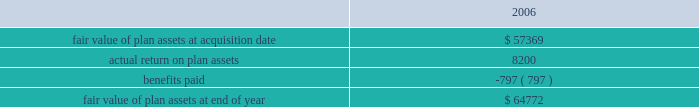For the valuation of the 4199466 performance-based options granted in 2005 : the risk free interest rate was 4.2% ( 4.2 % ) , the volatility factor for the expected market price of the common stock was 44% ( 44 % ) , the expected dividend yield was zero and the objective time to exercise was 4.7 years with an objective in the money assumption of 2.95 years .
It was also expected that the initial public offering assumption would occur within a 9 month period from grant date .
The fair value of the performance-based options was calculated to be $ 5.85 .
The fair value for fis options granted in 2006 was estimated at the date of grant using a black-scholes option- pricing model with the following weighted average assumptions .
The risk free interest rates used in the calculation are the rate that corresponds to the weighted average expected life of an option .
The risk free interest rate used for options granted during 2006 was 4.9% ( 4.9 % ) .
A volatility factor for the expected market price of the common stock of 30% ( 30 % ) was used for options granted in 2006 .
The expected dividend yield used for 2006 was 0.5% ( 0.5 % ) .
A weighted average expected life of 6.4 years was used for 2006 .
The weighted average fair value of each option granted during 2006 was $ 15.52 .
At december 31 , 2006 , the total unrecognized compensation cost related to non-vested stock option grants is $ 86.1 million , which is expected to be recognized in pre-tax income over a weighted average period of 1.9 years .
The company intends to limit dilution caused by option exercises , including anticipated exercises , by repurchasing shares on the open market or in privately negotiated transactions .
During 2006 , the company repurchased 4261200 shares at an average price of $ 37.60 .
On october 25 , 2006 , the company 2019s board of directors approved a plan authorizing the repurchase of up to an additional $ 200 million worth of the company 2019s common stock .
Defined benefit plans certegy pension plan in connection with the certegy merger , the company announced that it will terminate and settle the certegy u.s .
Retirement income plan ( usrip ) .
The estimated impact of this settlement was reflected in the purchase price allocation as an increase in the pension liability , less the fair value of the pension plan assets , based on estimates of the total cost to settle the liability through the purchase of annuity contracts or lump sum settlements to the beneficiaries .
The final settlement will not occur until after an irs determination has been obtained , which is expected to be received in 2007 .
In addition to the net pension plan obligation of $ 21.6 million , the company assumed liabilities of $ 8.0 million for certegy 2019s supplemental executive retirement plan ( 201cserp 201d ) and $ 3.0 mil- lion for a postretirement benefit plan .
A reconciliation of the changes in the fair value of plan assets of the usrip for the period from february 1 , 2006 through december 31 , 2006 is as follows ( in thousands ) : .
Benefits paid in the above table include only those amounts paid directly from plan assets .
As of december 31 , 2006 and for 2007 through the pay out of the pension liability , the assets are being invested in u.s .
Treasury bonds due to the short duration until final payment .
Fidelity national information services , inc .
And subsidiaries and affiliates consolidated and combined financial statements notes to consolidated and combined financial statements 2014 ( continued ) .
What is the percent increase in the fair value of plant asset after the acquisition date? 
Computations: ((64772 - 57369) / 57369)
Answer: 0.12904. 